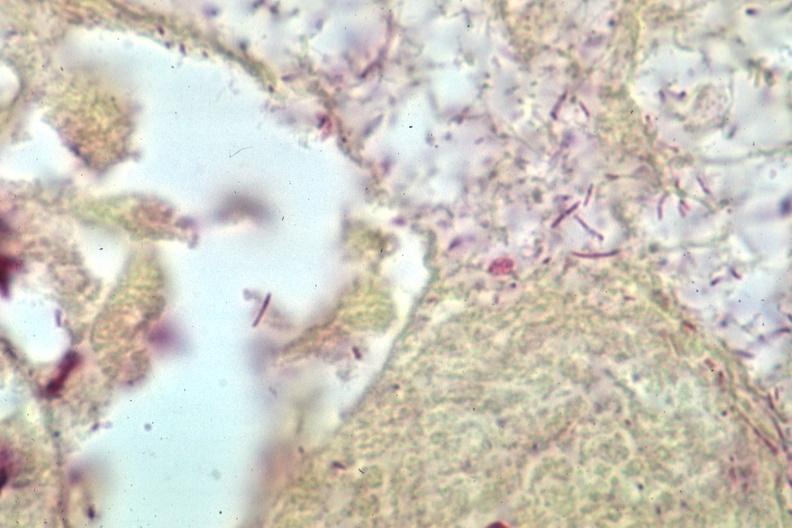what is present?
Answer the question using a single word or phrase. Meningitis purulent 